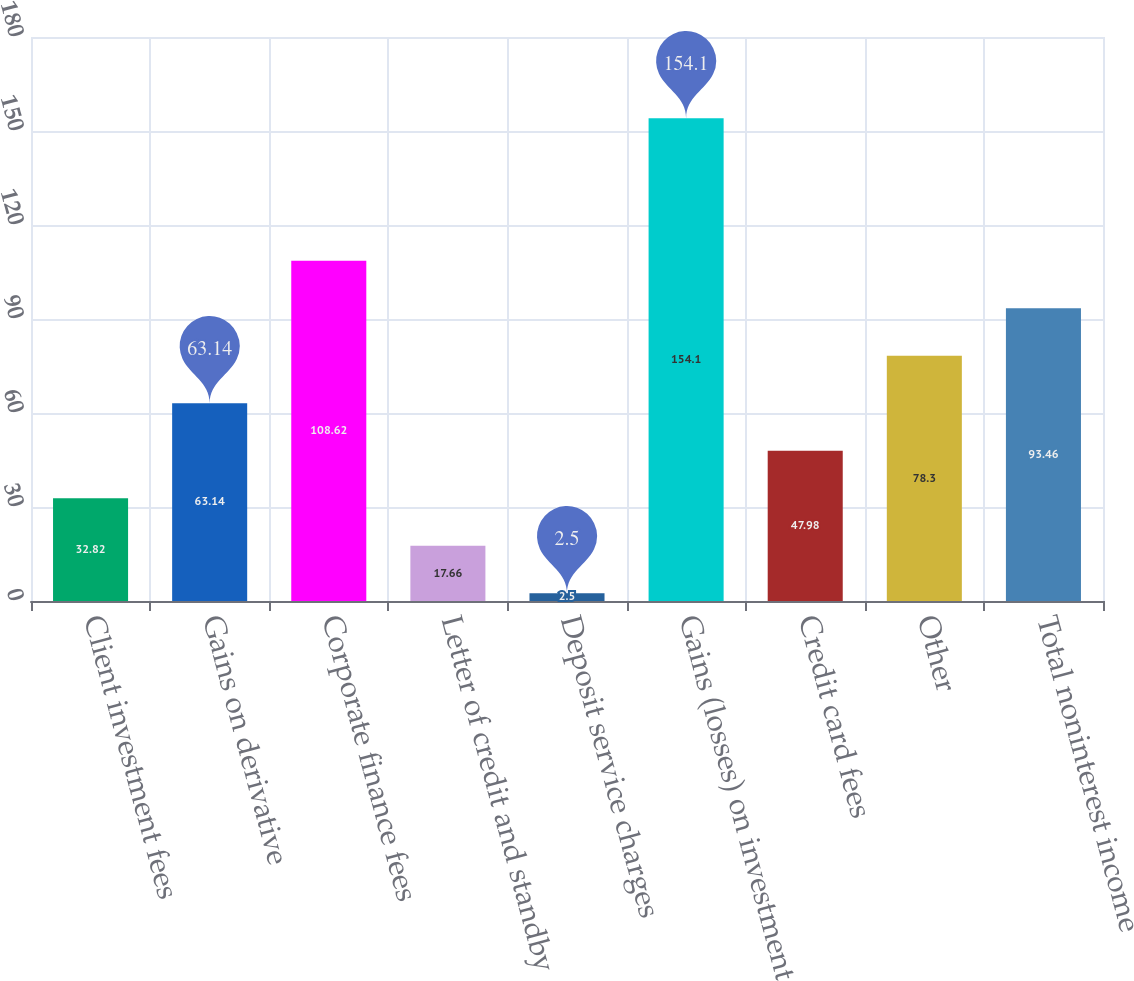<chart> <loc_0><loc_0><loc_500><loc_500><bar_chart><fcel>Client investment fees<fcel>Gains on derivative<fcel>Corporate finance fees<fcel>Letter of credit and standby<fcel>Deposit service charges<fcel>Gains (losses) on investment<fcel>Credit card fees<fcel>Other<fcel>Total noninterest income<nl><fcel>32.82<fcel>63.14<fcel>108.62<fcel>17.66<fcel>2.5<fcel>154.1<fcel>47.98<fcel>78.3<fcel>93.46<nl></chart> 